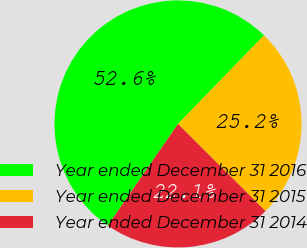Convert chart. <chart><loc_0><loc_0><loc_500><loc_500><pie_chart><fcel>Year ended December 31 2016<fcel>Year ended December 31 2015<fcel>Year ended December 31 2014<nl><fcel>52.65%<fcel>25.2%<fcel>22.15%<nl></chart> 